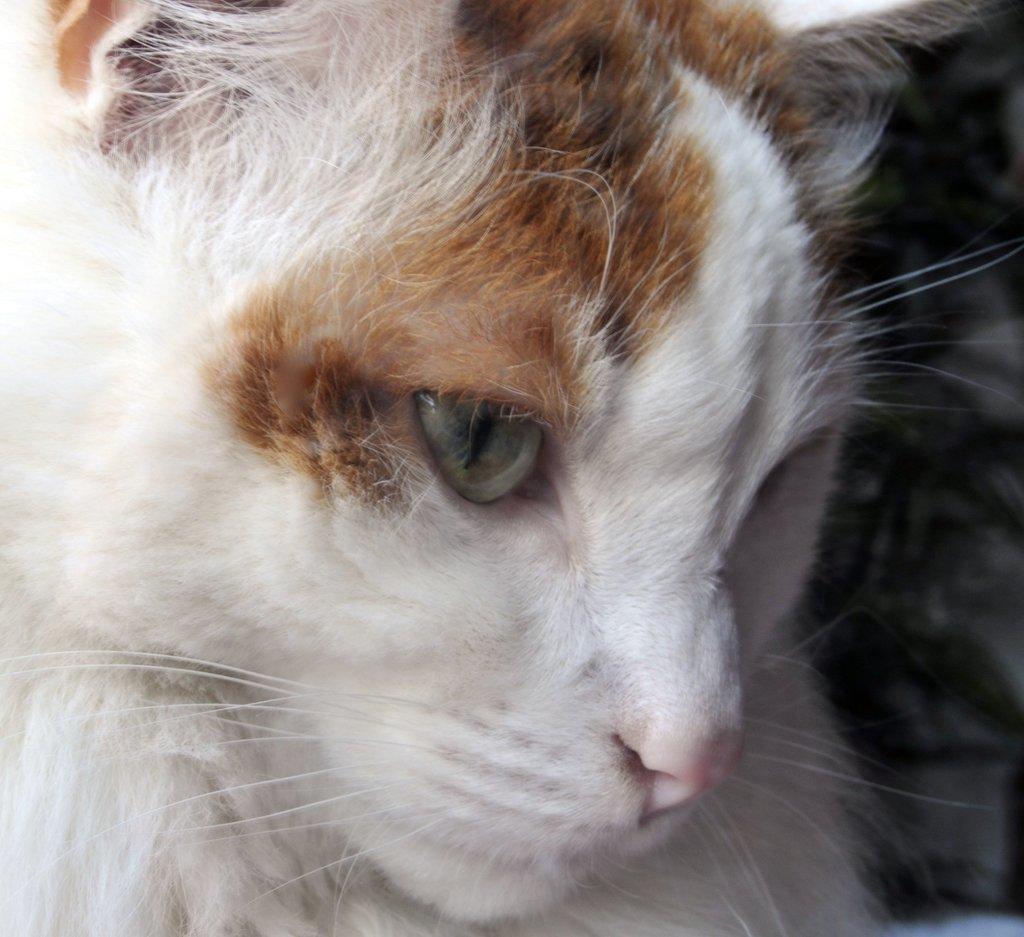How would you summarize this image in a sentence or two? In this image I can see the cat and the cat is in brown and white color. 